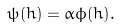<formula> <loc_0><loc_0><loc_500><loc_500>\psi ( h ) = \alpha \phi ( h ) .</formula> 